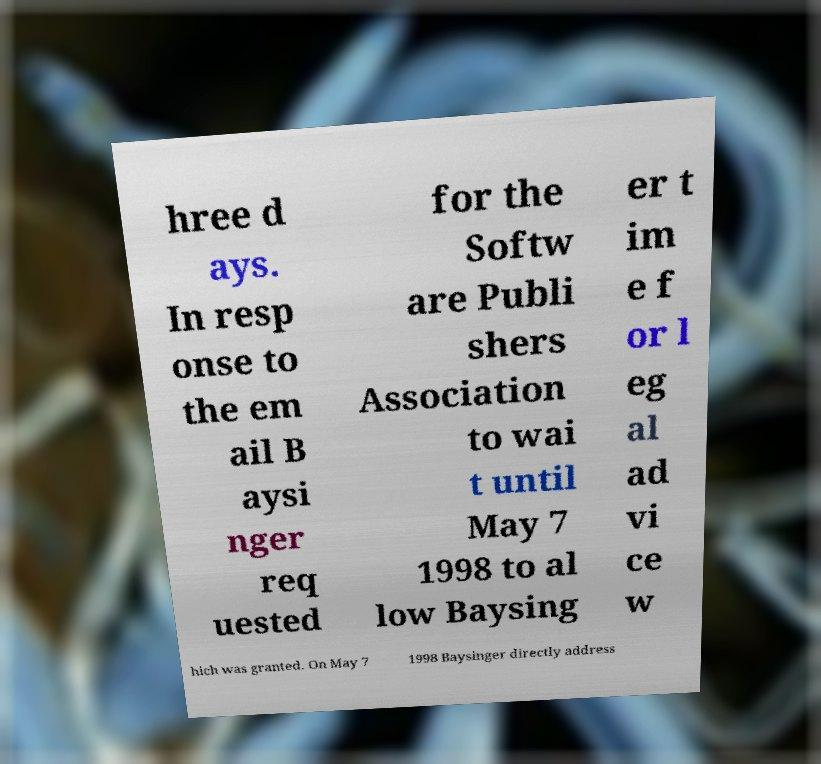Could you extract and type out the text from this image? hree d ays. In resp onse to the em ail B aysi nger req uested for the Softw are Publi shers Association to wai t until May 7 1998 to al low Baysing er t im e f or l eg al ad vi ce w hich was granted. On May 7 1998 Baysinger directly address 